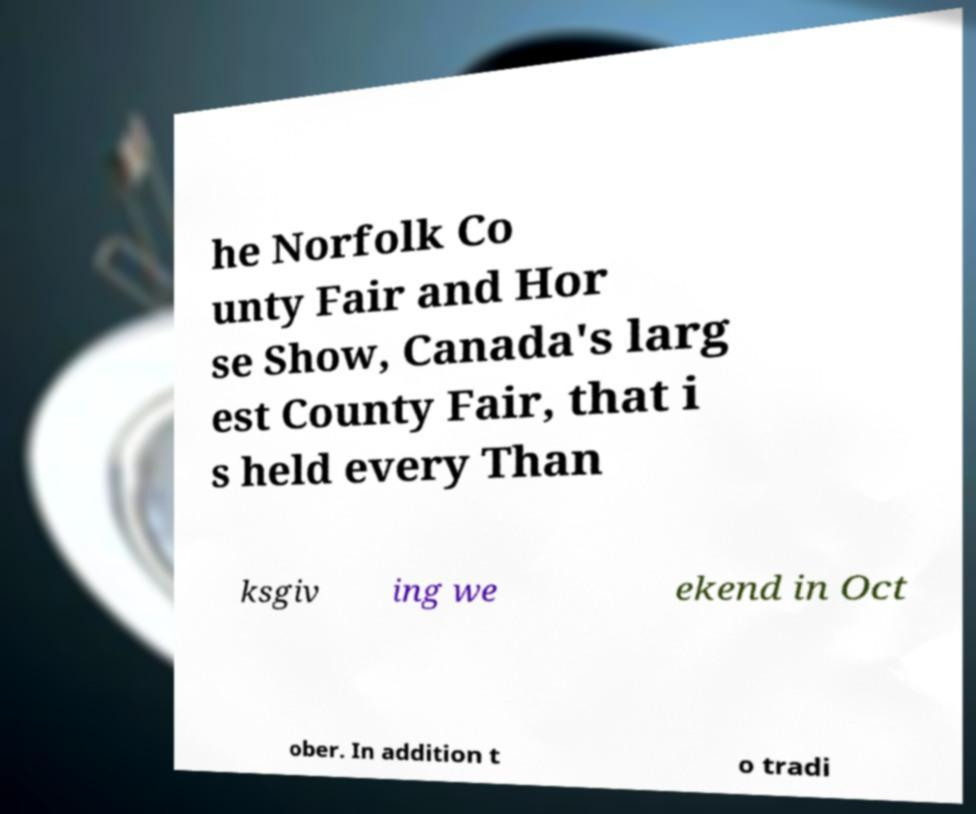Could you extract and type out the text from this image? he Norfolk Co unty Fair and Hor se Show, Canada's larg est County Fair, that i s held every Than ksgiv ing we ekend in Oct ober. In addition t o tradi 